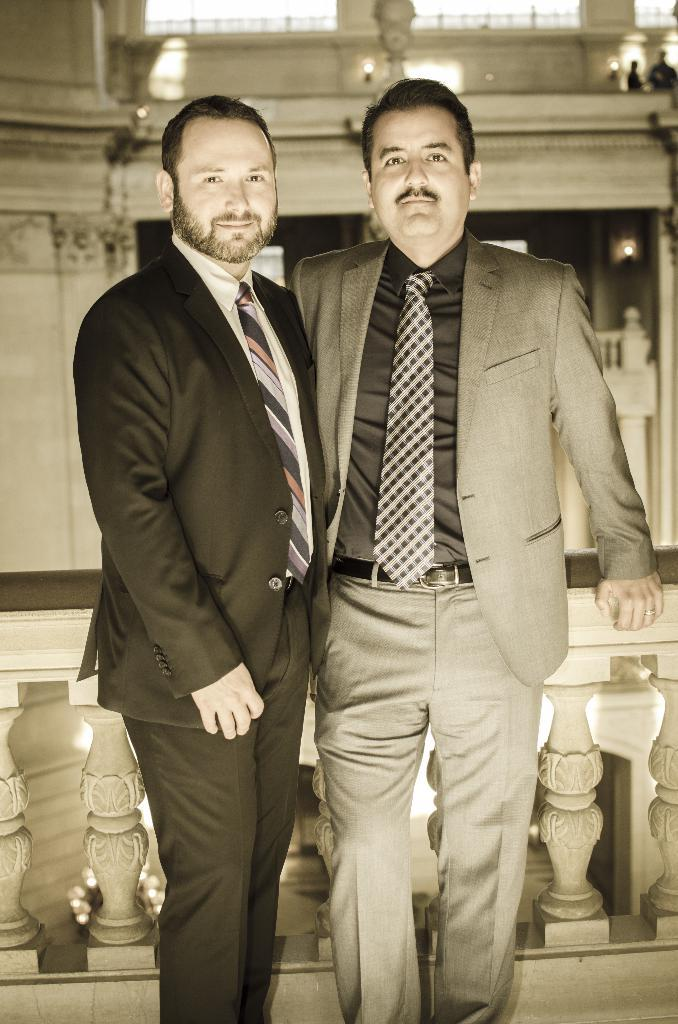How many men are present in the image? There are two men standing in the image. What are the men doing in the image? The men are standing at a fence. What can be seen in the background of the image? There are lights and at least a few persons visible in the background of the image. What is present in the background of the image? There is a fence in the background of the image. What type of cork is being used to prevent the destruction of the fence in the image? There is no mention of a cork or any destruction in the image; it simply shows two men standing at a fence. 